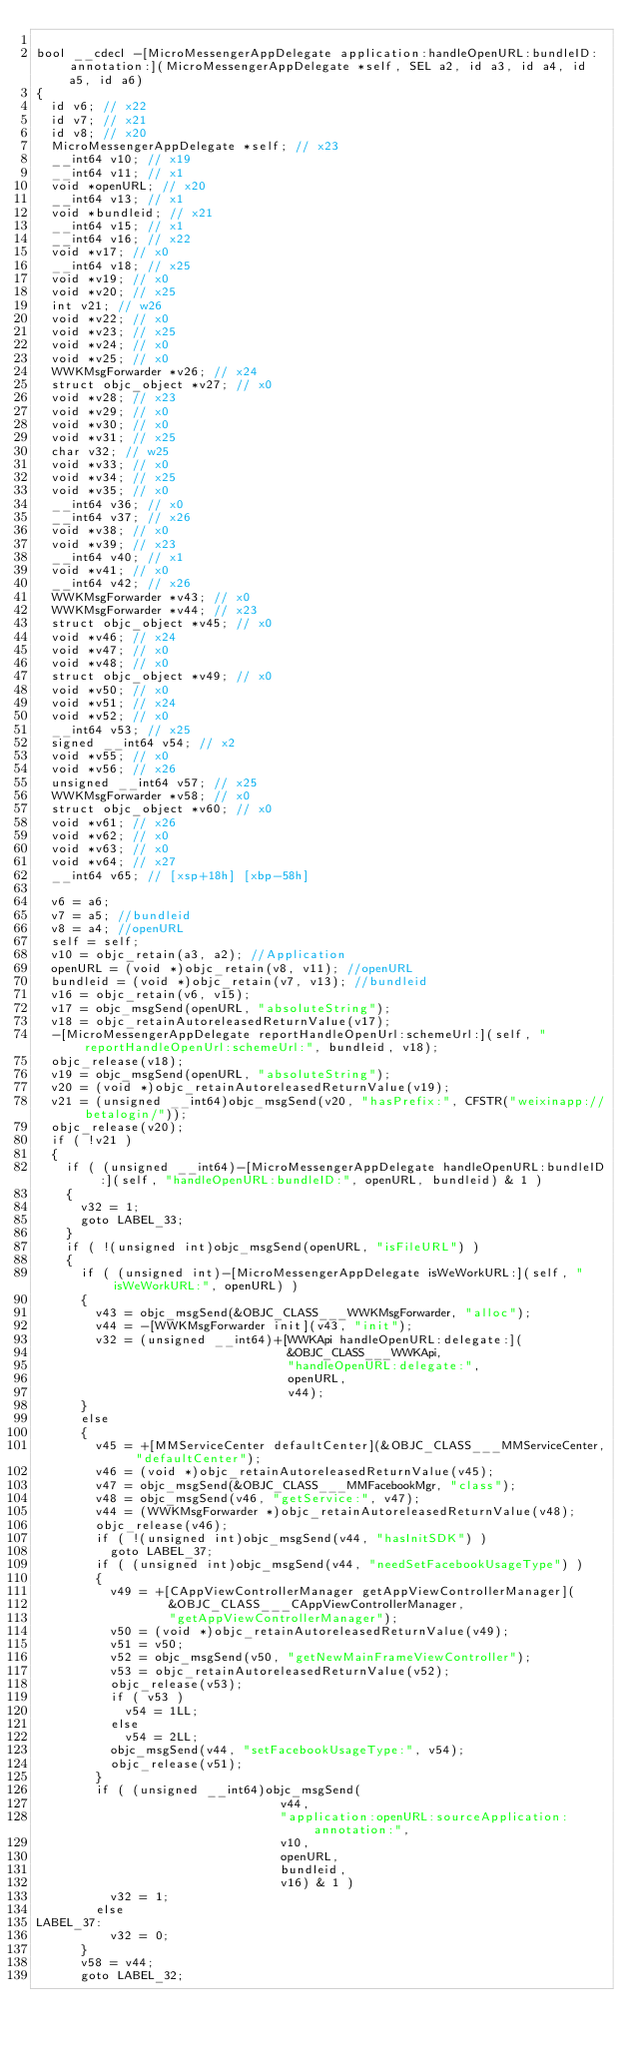Convert code to text. <code><loc_0><loc_0><loc_500><loc_500><_ObjectiveC_>
bool __cdecl -[MicroMessengerAppDelegate application:handleOpenURL:bundleID:annotation:](MicroMessengerAppDelegate *self, SEL a2, id a3, id a4, id a5, id a6)
{
  id v6; // x22
  id v7; // x21
  id v8; // x20
  MicroMessengerAppDelegate *self; // x23
  __int64 v10; // x19
  __int64 v11; // x1
  void *openURL; // x20
  __int64 v13; // x1
  void *bundleid; // x21
  __int64 v15; // x1
  __int64 v16; // x22
  void *v17; // x0
  __int64 v18; // x25
  void *v19; // x0
  void *v20; // x25
  int v21; // w26
  void *v22; // x0
  void *v23; // x25
  void *v24; // x0
  void *v25; // x0
  WWKMsgForwarder *v26; // x24
  struct objc_object *v27; // x0
  void *v28; // x23
  void *v29; // x0
  void *v30; // x0
  void *v31; // x25
  char v32; // w25
  void *v33; // x0
  void *v34; // x25
  void *v35; // x0
  __int64 v36; // x0
  __int64 v37; // x26
  void *v38; // x0
  void *v39; // x23
  __int64 v40; // x1
  void *v41; // x0
  __int64 v42; // x26
  WWKMsgForwarder *v43; // x0
  WWKMsgForwarder *v44; // x23
  struct objc_object *v45; // x0
  void *v46; // x24
  void *v47; // x0
  void *v48; // x0
  struct objc_object *v49; // x0
  void *v50; // x0
  void *v51; // x24
  void *v52; // x0
  __int64 v53; // x25
  signed __int64 v54; // x2
  void *v55; // x0
  void *v56; // x26
  unsigned __int64 v57; // x25
  WWKMsgForwarder *v58; // x0
  struct objc_object *v60; // x0
  void *v61; // x26
  void *v62; // x0
  void *v63; // x0
  void *v64; // x27
  __int64 v65; // [xsp+18h] [xbp-58h]

  v6 = a6;
  v7 = a5; //bundleid
  v8 = a4; //openURL
  self = self;
  v10 = objc_retain(a3, a2); //Application
  openURL = (void *)objc_retain(v8, v11); //openURL
  bundleid = (void *)objc_retain(v7, v13); //bundleid
  v16 = objc_retain(v6, v15);
  v17 = objc_msgSend(openURL, "absoluteString");
  v18 = objc_retainAutoreleasedReturnValue(v17);
  -[MicroMessengerAppDelegate reportHandleOpenUrl:schemeUrl:](self, "reportHandleOpenUrl:schemeUrl:", bundleid, v18);
  objc_release(v18);
  v19 = objc_msgSend(openURL, "absoluteString");
  v20 = (void *)objc_retainAutoreleasedReturnValue(v19);
  v21 = (unsigned __int64)objc_msgSend(v20, "hasPrefix:", CFSTR("weixinapp://betalogin/"));
  objc_release(v20);
  if ( !v21 )
  {
    if ( (unsigned __int64)-[MicroMessengerAppDelegate handleOpenURL:bundleID:](self, "handleOpenURL:bundleID:", openURL, bundleid) & 1 )
    {
      v32 = 1;
      goto LABEL_33;
    }
    if ( !(unsigned int)objc_msgSend(openURL, "isFileURL") )
    {
      if ( (unsigned int)-[MicroMessengerAppDelegate isWeWorkURL:](self, "isWeWorkURL:", openURL) )
      {
        v43 = objc_msgSend(&OBJC_CLASS___WWKMsgForwarder, "alloc");
        v44 = -[WWKMsgForwarder init](v43, "init");
        v32 = (unsigned __int64)+[WWKApi handleOpenURL:delegate:](
                                  &OBJC_CLASS___WWKApi,
                                  "handleOpenURL:delegate:",
                                  openURL,
                                  v44);
      }
      else
      {
        v45 = +[MMServiceCenter defaultCenter](&OBJC_CLASS___MMServiceCenter, "defaultCenter");
        v46 = (void *)objc_retainAutoreleasedReturnValue(v45);
        v47 = objc_msgSend(&OBJC_CLASS___MMFacebookMgr, "class");
        v48 = objc_msgSend(v46, "getService:", v47);
        v44 = (WWKMsgForwarder *)objc_retainAutoreleasedReturnValue(v48);
        objc_release(v46);
        if ( !(unsigned int)objc_msgSend(v44, "hasInitSDK") )
          goto LABEL_37;
        if ( (unsigned int)objc_msgSend(v44, "needSetFacebookUsageType") )
        {
          v49 = +[CAppViewControllerManager getAppViewControllerManager](
                  &OBJC_CLASS___CAppViewControllerManager,
                  "getAppViewControllerManager");
          v50 = (void *)objc_retainAutoreleasedReturnValue(v49);
          v51 = v50;
          v52 = objc_msgSend(v50, "getNewMainFrameViewController");
          v53 = objc_retainAutoreleasedReturnValue(v52);
          objc_release(v53);
          if ( v53 )
            v54 = 1LL;
          else
            v54 = 2LL;
          objc_msgSend(v44, "setFacebookUsageType:", v54);
          objc_release(v51);
        }
        if ( (unsigned __int64)objc_msgSend(
                                 v44,
                                 "application:openURL:sourceApplication:annotation:",
                                 v10,
                                 openURL,
                                 bundleid,
                                 v16) & 1 )
          v32 = 1;
        else
LABEL_37:
          v32 = 0;
      }
      v58 = v44;
      goto LABEL_32;</code> 